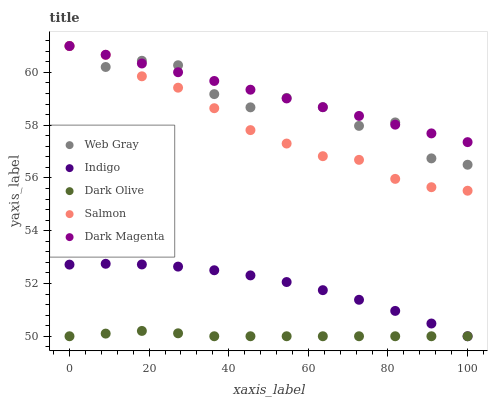Does Dark Olive have the minimum area under the curve?
Answer yes or no. Yes. Does Dark Magenta have the maximum area under the curve?
Answer yes or no. Yes. Does Salmon have the minimum area under the curve?
Answer yes or no. No. Does Salmon have the maximum area under the curve?
Answer yes or no. No. Is Dark Magenta the smoothest?
Answer yes or no. Yes. Is Web Gray the roughest?
Answer yes or no. Yes. Is Salmon the smoothest?
Answer yes or no. No. Is Salmon the roughest?
Answer yes or no. No. Does Dark Olive have the lowest value?
Answer yes or no. Yes. Does Salmon have the lowest value?
Answer yes or no. No. Does Dark Magenta have the highest value?
Answer yes or no. Yes. Does Indigo have the highest value?
Answer yes or no. No. Is Dark Olive less than Salmon?
Answer yes or no. Yes. Is Dark Magenta greater than Dark Olive?
Answer yes or no. Yes. Does Web Gray intersect Dark Magenta?
Answer yes or no. Yes. Is Web Gray less than Dark Magenta?
Answer yes or no. No. Is Web Gray greater than Dark Magenta?
Answer yes or no. No. Does Dark Olive intersect Salmon?
Answer yes or no. No. 